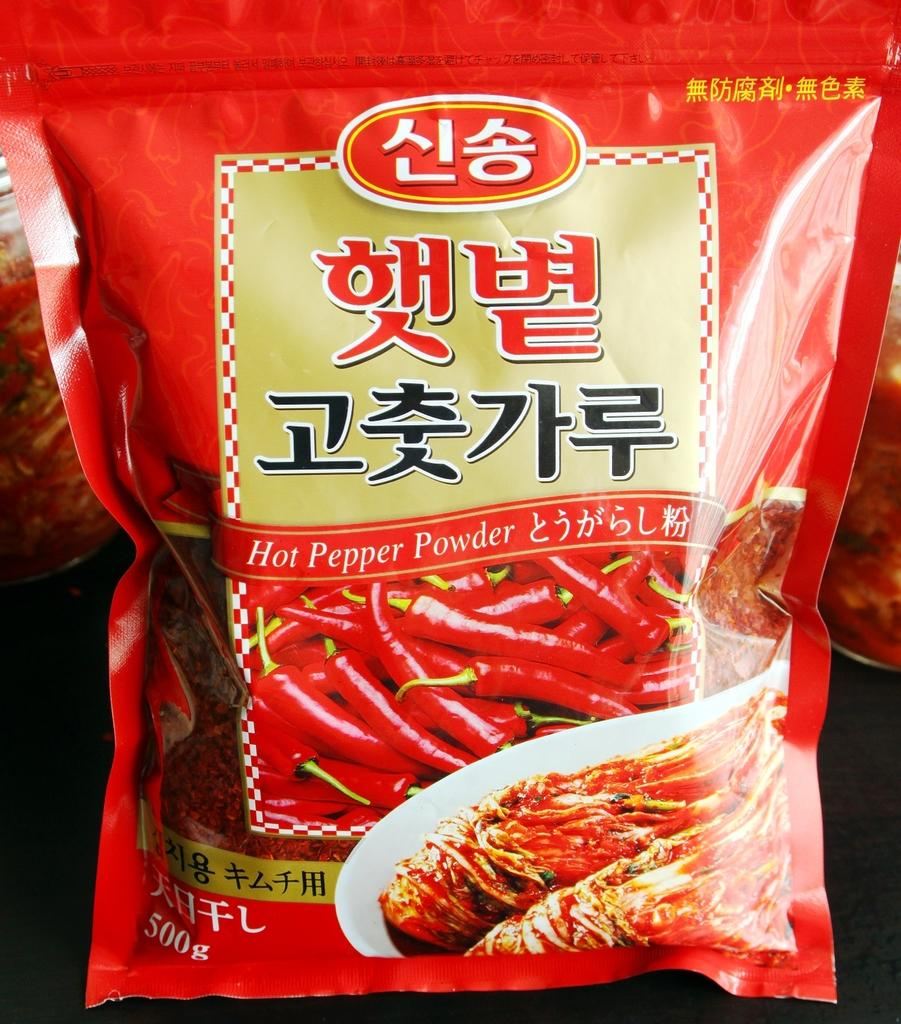What is the main subject of the image? The main subject of the image is a red packet. What is depicted on the red packet? The packet has red chilies depicted on it. What is the purpose of the red packet? The packet is labeled as "Hot Pepper powder". What action is the red packet performing in the image? The red packet is not performing any action in the image; it is simply a stationary object. 